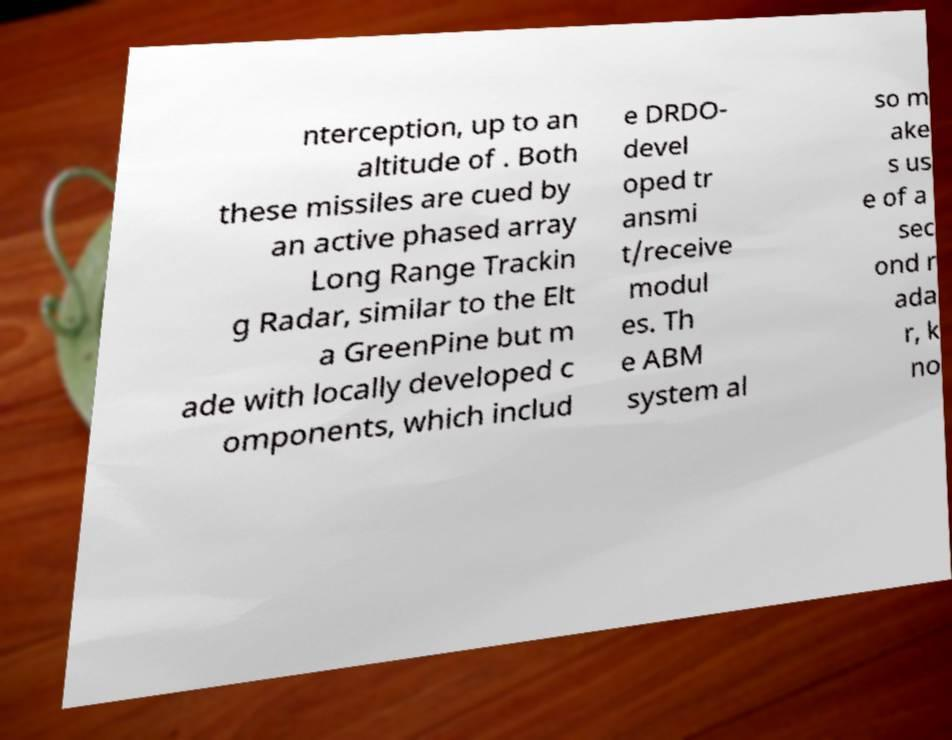Could you extract and type out the text from this image? nterception, up to an altitude of . Both these missiles are cued by an active phased array Long Range Trackin g Radar, similar to the Elt a GreenPine but m ade with locally developed c omponents, which includ e DRDO- devel oped tr ansmi t/receive modul es. Th e ABM system al so m ake s us e of a sec ond r ada r, k no 